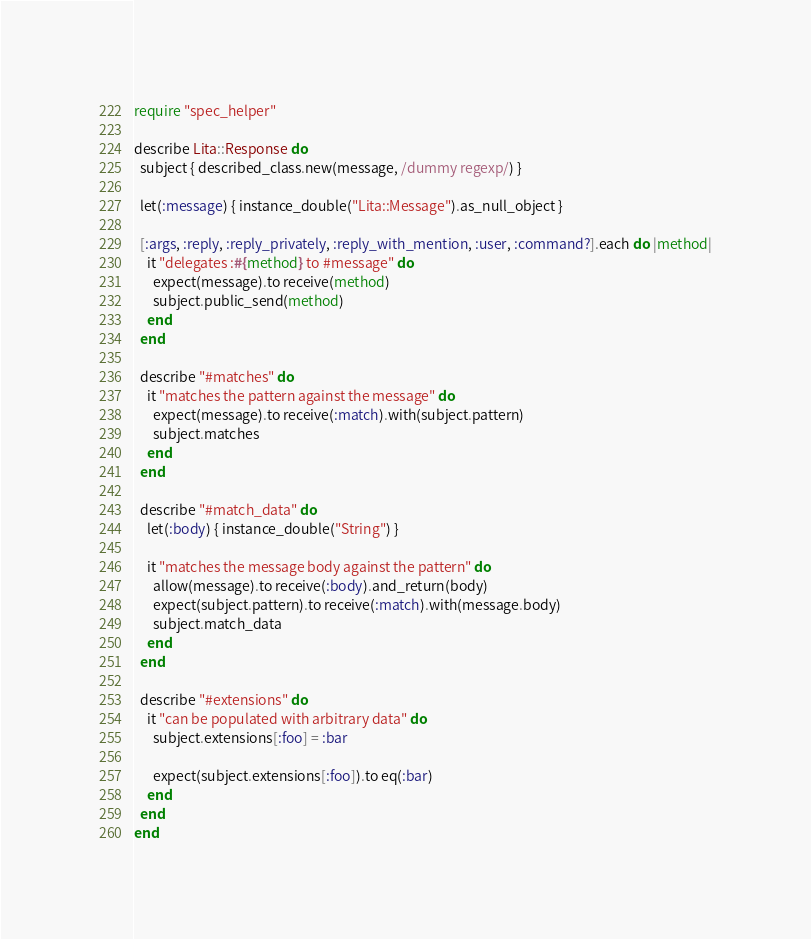<code> <loc_0><loc_0><loc_500><loc_500><_Ruby_>require "spec_helper"

describe Lita::Response do
  subject { described_class.new(message, /dummy regexp/) }

  let(:message) { instance_double("Lita::Message").as_null_object }

  [:args, :reply, :reply_privately, :reply_with_mention, :user, :command?].each do |method|
    it "delegates :#{method} to #message" do
      expect(message).to receive(method)
      subject.public_send(method)
    end
  end

  describe "#matches" do
    it "matches the pattern against the message" do
      expect(message).to receive(:match).with(subject.pattern)
      subject.matches
    end
  end

  describe "#match_data" do
    let(:body) { instance_double("String") }

    it "matches the message body against the pattern" do
      allow(message).to receive(:body).and_return(body)
      expect(subject.pattern).to receive(:match).with(message.body)
      subject.match_data
    end
  end

  describe "#extensions" do
    it "can be populated with arbitrary data" do
      subject.extensions[:foo] = :bar

      expect(subject.extensions[:foo]).to eq(:bar)
    end
  end
end
</code> 